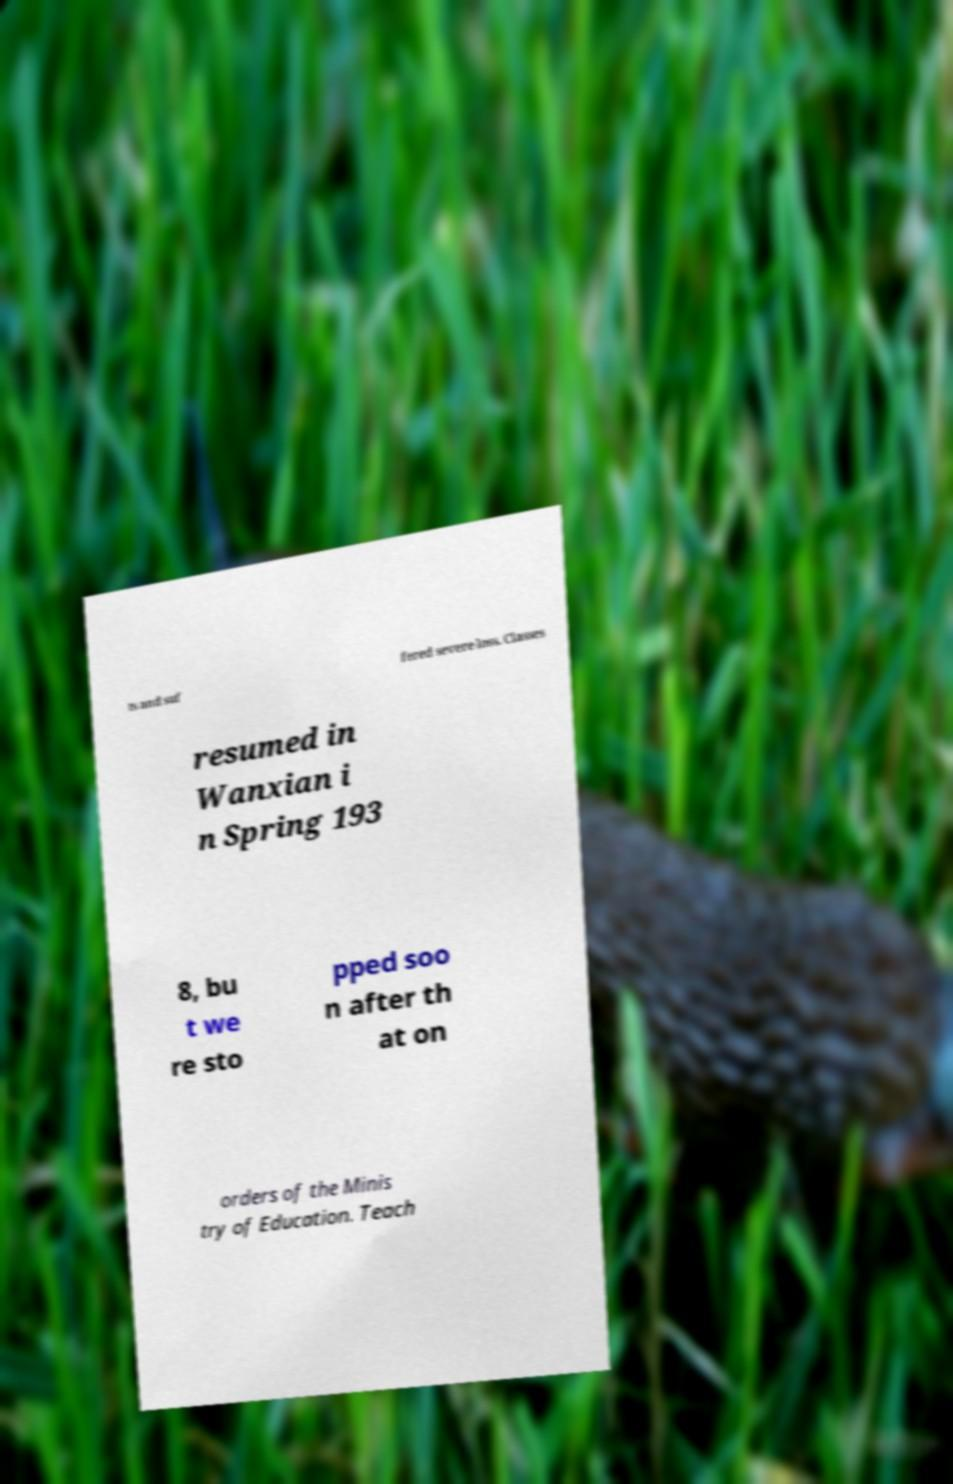Could you extract and type out the text from this image? ts and suf fered severe loss. Classes resumed in Wanxian i n Spring 193 8, bu t we re sto pped soo n after th at on orders of the Minis try of Education. Teach 